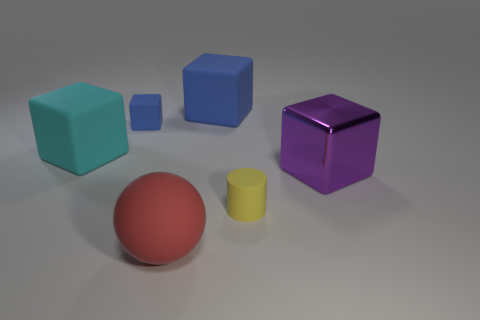Is there a yellow thing that has the same size as the purple shiny thing? In the image, the yellow object, which appears to be a small cylinder, has a smaller size than the purple object, which seems to be a cube with a reflective surface. 